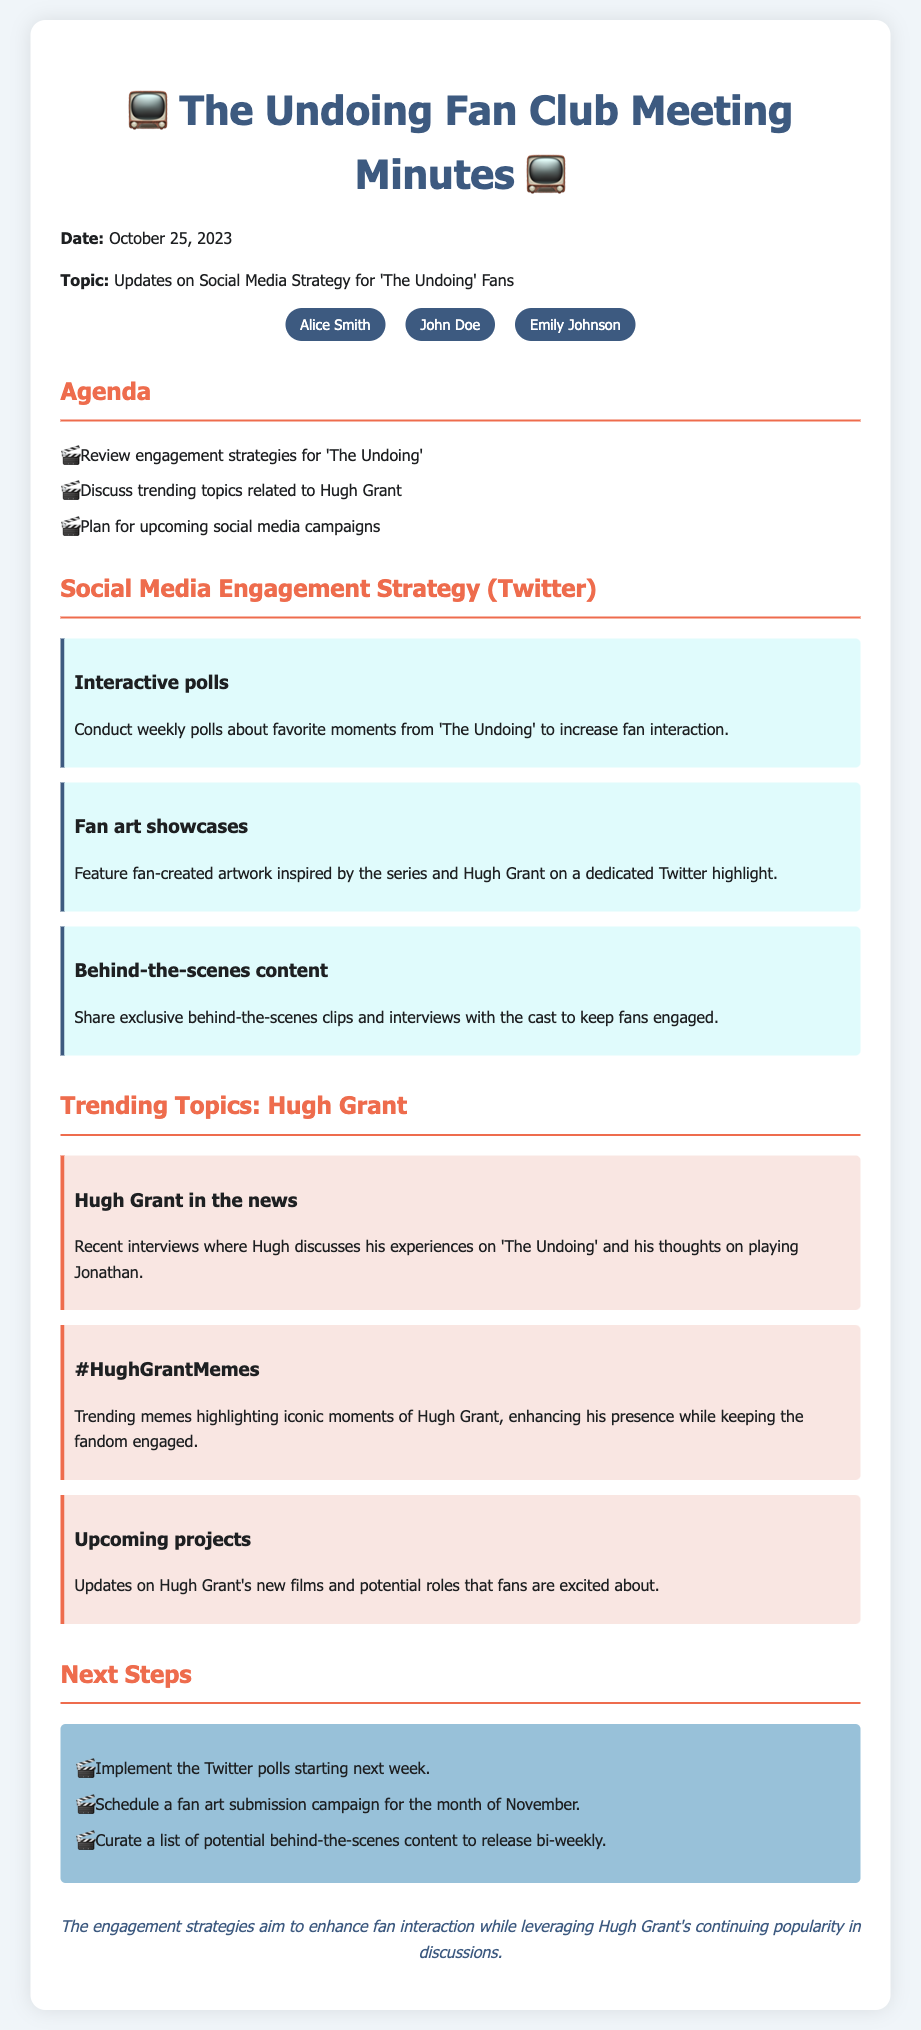What is the date of the meeting? The date of the meeting is explicitly mentioned in the document.
Answer: October 25, 2023 Who is one of the attendees? The document lists attendees of the meeting, providing individual names.
Answer: Alice Smith What is one of the engagement strategies discussed? The document outlines several engagement strategies in a dedicated section.
Answer: Interactive polls What is a trending topic related to Hugh Grant? The document provides multiple trending topics, one of which is directly related to Hugh Grant.
Answer: Hugh Grant in the news What is one of the next steps planned after the meeting? The document includes a list of next steps intended to be implemented post-meeting.
Answer: Implement the Twitter polls What role does Hugh Grant play in 'The Undoing'? The document references Hugh Grant's involvement in 'The Undoing', mentioning his character.
Answer: Jonathan How many attendees are mentioned in the meeting? The total number of attendees is indicated at the beginning of the attendees' section.
Answer: Three What type of content will be scheduled bi-weekly? The document outlines specific content that will be released on a regular basis.
Answer: Behind-the-scenes content What is the main focus of the meeting? The primary topic discussed in the meeting is specified at the start of the document.
Answer: Social Media Strategy for 'The Undoing' Fans 